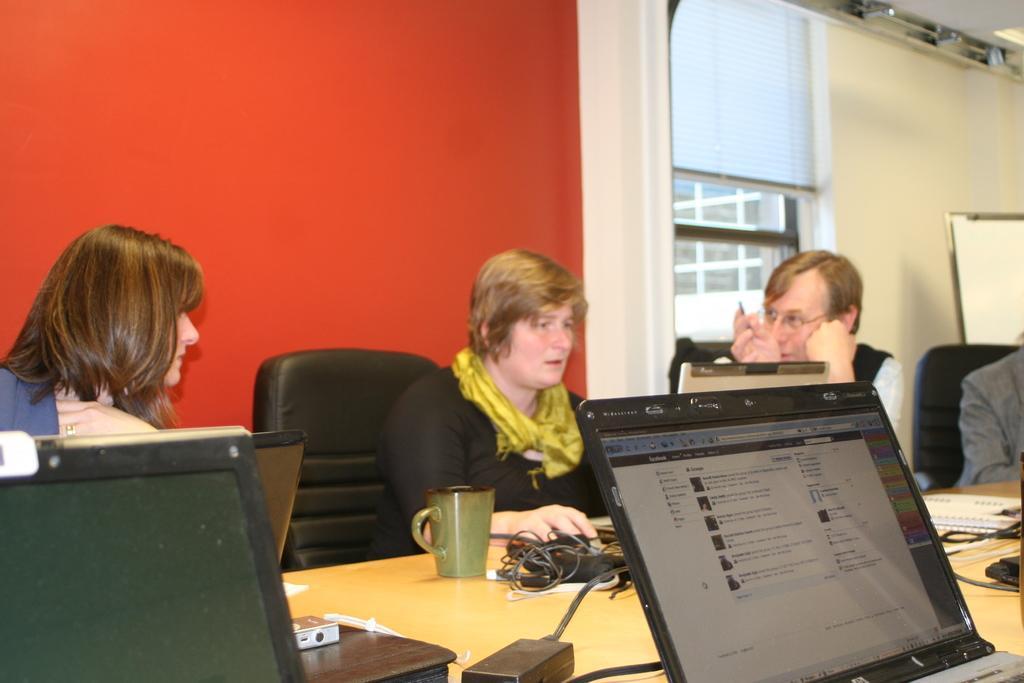How would you summarize this image in a sentence or two? In the picture it looks like there is a table and people around it. On the table there is cup,laptops,charging wires,books on it. In the middle there is a woman who is sitting in chair and working with the laptop which is in front of her. At the back side there is wall and window. 